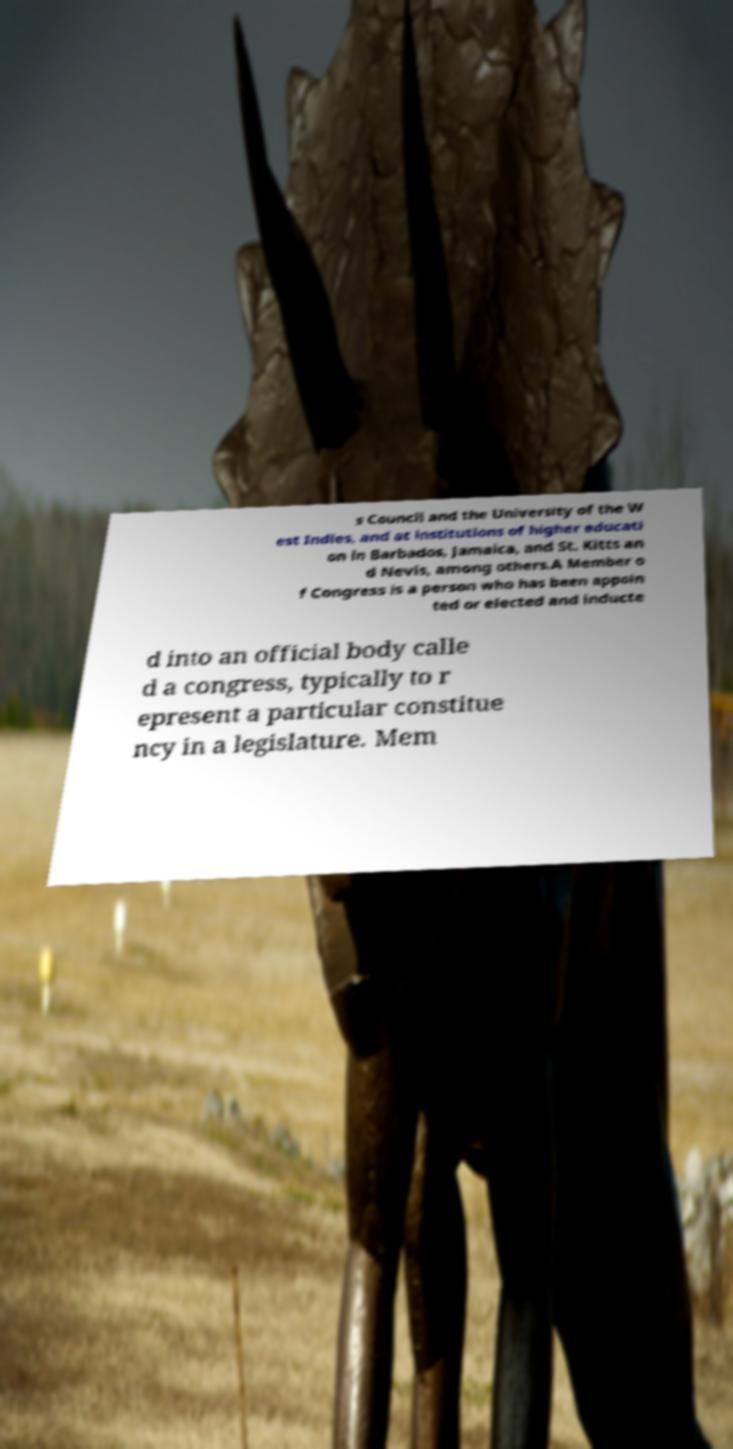Could you extract and type out the text from this image? s Council and the University of the W est Indies, and at institutions of higher educati on in Barbados, Jamaica, and St. Kitts an d Nevis, among others.A Member o f Congress is a person who has been appoin ted or elected and inducte d into an official body calle d a congress, typically to r epresent a particular constitue ncy in a legislature. Mem 